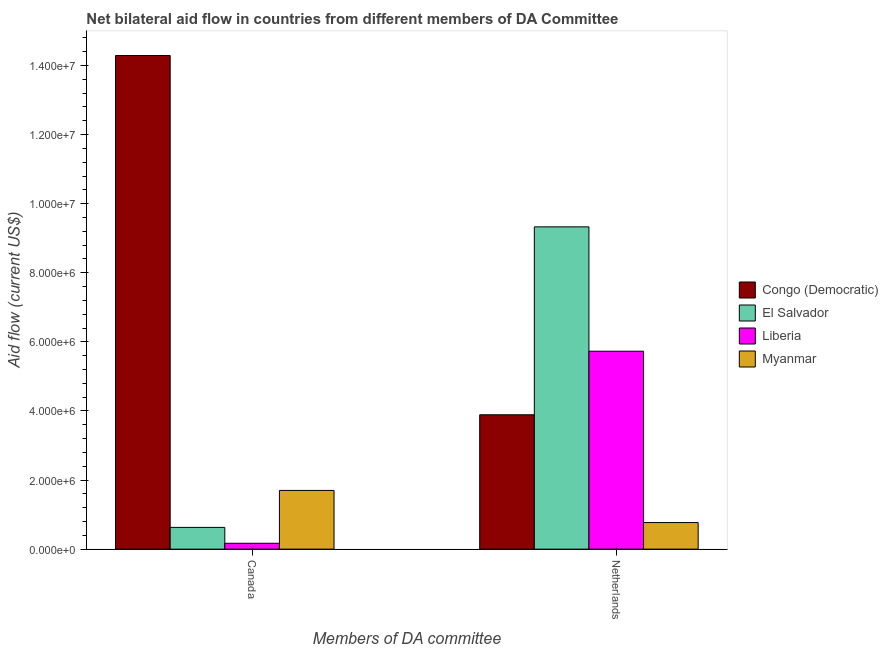How many different coloured bars are there?
Offer a terse response. 4. How many groups of bars are there?
Provide a short and direct response. 2. Are the number of bars per tick equal to the number of legend labels?
Your answer should be very brief. Yes. How many bars are there on the 2nd tick from the right?
Provide a succinct answer. 4. What is the amount of aid given by netherlands in Congo (Democratic)?
Keep it short and to the point. 3.89e+06. Across all countries, what is the maximum amount of aid given by canada?
Your answer should be very brief. 1.43e+07. Across all countries, what is the minimum amount of aid given by netherlands?
Give a very brief answer. 7.70e+05. In which country was the amount of aid given by netherlands maximum?
Offer a very short reply. El Salvador. In which country was the amount of aid given by netherlands minimum?
Provide a short and direct response. Myanmar. What is the total amount of aid given by netherlands in the graph?
Offer a terse response. 1.97e+07. What is the difference between the amount of aid given by canada in Myanmar and that in Liberia?
Your answer should be very brief. 1.53e+06. What is the difference between the amount of aid given by netherlands in Liberia and the amount of aid given by canada in Congo (Democratic)?
Your answer should be very brief. -8.56e+06. What is the average amount of aid given by netherlands per country?
Give a very brief answer. 4.93e+06. What is the difference between the amount of aid given by netherlands and amount of aid given by canada in Liberia?
Offer a terse response. 5.56e+06. What is the ratio of the amount of aid given by netherlands in Liberia to that in Myanmar?
Offer a very short reply. 7.44. In how many countries, is the amount of aid given by netherlands greater than the average amount of aid given by netherlands taken over all countries?
Provide a short and direct response. 2. What does the 3rd bar from the left in Canada represents?
Ensure brevity in your answer.  Liberia. What does the 2nd bar from the right in Netherlands represents?
Offer a terse response. Liberia. Are the values on the major ticks of Y-axis written in scientific E-notation?
Your response must be concise. Yes. Does the graph contain any zero values?
Your answer should be very brief. No. Where does the legend appear in the graph?
Ensure brevity in your answer.  Center right. How are the legend labels stacked?
Your answer should be compact. Vertical. What is the title of the graph?
Your answer should be very brief. Net bilateral aid flow in countries from different members of DA Committee. Does "Serbia" appear as one of the legend labels in the graph?
Your response must be concise. No. What is the label or title of the X-axis?
Keep it short and to the point. Members of DA committee. What is the label or title of the Y-axis?
Ensure brevity in your answer.  Aid flow (current US$). What is the Aid flow (current US$) in Congo (Democratic) in Canada?
Ensure brevity in your answer.  1.43e+07. What is the Aid flow (current US$) in El Salvador in Canada?
Offer a terse response. 6.30e+05. What is the Aid flow (current US$) of Liberia in Canada?
Give a very brief answer. 1.70e+05. What is the Aid flow (current US$) of Myanmar in Canada?
Give a very brief answer. 1.70e+06. What is the Aid flow (current US$) in Congo (Democratic) in Netherlands?
Give a very brief answer. 3.89e+06. What is the Aid flow (current US$) in El Salvador in Netherlands?
Your response must be concise. 9.33e+06. What is the Aid flow (current US$) of Liberia in Netherlands?
Ensure brevity in your answer.  5.73e+06. What is the Aid flow (current US$) in Myanmar in Netherlands?
Your response must be concise. 7.70e+05. Across all Members of DA committee, what is the maximum Aid flow (current US$) of Congo (Democratic)?
Your response must be concise. 1.43e+07. Across all Members of DA committee, what is the maximum Aid flow (current US$) in El Salvador?
Make the answer very short. 9.33e+06. Across all Members of DA committee, what is the maximum Aid flow (current US$) in Liberia?
Make the answer very short. 5.73e+06. Across all Members of DA committee, what is the maximum Aid flow (current US$) in Myanmar?
Provide a succinct answer. 1.70e+06. Across all Members of DA committee, what is the minimum Aid flow (current US$) in Congo (Democratic)?
Give a very brief answer. 3.89e+06. Across all Members of DA committee, what is the minimum Aid flow (current US$) of El Salvador?
Give a very brief answer. 6.30e+05. Across all Members of DA committee, what is the minimum Aid flow (current US$) in Liberia?
Make the answer very short. 1.70e+05. Across all Members of DA committee, what is the minimum Aid flow (current US$) in Myanmar?
Give a very brief answer. 7.70e+05. What is the total Aid flow (current US$) of Congo (Democratic) in the graph?
Offer a terse response. 1.82e+07. What is the total Aid flow (current US$) in El Salvador in the graph?
Offer a terse response. 9.96e+06. What is the total Aid flow (current US$) in Liberia in the graph?
Your answer should be compact. 5.90e+06. What is the total Aid flow (current US$) of Myanmar in the graph?
Make the answer very short. 2.47e+06. What is the difference between the Aid flow (current US$) of Congo (Democratic) in Canada and that in Netherlands?
Provide a succinct answer. 1.04e+07. What is the difference between the Aid flow (current US$) of El Salvador in Canada and that in Netherlands?
Keep it short and to the point. -8.70e+06. What is the difference between the Aid flow (current US$) of Liberia in Canada and that in Netherlands?
Your answer should be very brief. -5.56e+06. What is the difference between the Aid flow (current US$) of Myanmar in Canada and that in Netherlands?
Provide a succinct answer. 9.30e+05. What is the difference between the Aid flow (current US$) of Congo (Democratic) in Canada and the Aid flow (current US$) of El Salvador in Netherlands?
Provide a succinct answer. 4.96e+06. What is the difference between the Aid flow (current US$) of Congo (Democratic) in Canada and the Aid flow (current US$) of Liberia in Netherlands?
Provide a succinct answer. 8.56e+06. What is the difference between the Aid flow (current US$) in Congo (Democratic) in Canada and the Aid flow (current US$) in Myanmar in Netherlands?
Keep it short and to the point. 1.35e+07. What is the difference between the Aid flow (current US$) of El Salvador in Canada and the Aid flow (current US$) of Liberia in Netherlands?
Offer a terse response. -5.10e+06. What is the difference between the Aid flow (current US$) in El Salvador in Canada and the Aid flow (current US$) in Myanmar in Netherlands?
Keep it short and to the point. -1.40e+05. What is the difference between the Aid flow (current US$) in Liberia in Canada and the Aid flow (current US$) in Myanmar in Netherlands?
Your response must be concise. -6.00e+05. What is the average Aid flow (current US$) of Congo (Democratic) per Members of DA committee?
Give a very brief answer. 9.09e+06. What is the average Aid flow (current US$) of El Salvador per Members of DA committee?
Ensure brevity in your answer.  4.98e+06. What is the average Aid flow (current US$) in Liberia per Members of DA committee?
Offer a very short reply. 2.95e+06. What is the average Aid flow (current US$) in Myanmar per Members of DA committee?
Your answer should be very brief. 1.24e+06. What is the difference between the Aid flow (current US$) in Congo (Democratic) and Aid flow (current US$) in El Salvador in Canada?
Keep it short and to the point. 1.37e+07. What is the difference between the Aid flow (current US$) of Congo (Democratic) and Aid flow (current US$) of Liberia in Canada?
Offer a terse response. 1.41e+07. What is the difference between the Aid flow (current US$) in Congo (Democratic) and Aid flow (current US$) in Myanmar in Canada?
Ensure brevity in your answer.  1.26e+07. What is the difference between the Aid flow (current US$) in El Salvador and Aid flow (current US$) in Liberia in Canada?
Make the answer very short. 4.60e+05. What is the difference between the Aid flow (current US$) in El Salvador and Aid flow (current US$) in Myanmar in Canada?
Your answer should be very brief. -1.07e+06. What is the difference between the Aid flow (current US$) of Liberia and Aid flow (current US$) of Myanmar in Canada?
Give a very brief answer. -1.53e+06. What is the difference between the Aid flow (current US$) of Congo (Democratic) and Aid flow (current US$) of El Salvador in Netherlands?
Your answer should be very brief. -5.44e+06. What is the difference between the Aid flow (current US$) of Congo (Democratic) and Aid flow (current US$) of Liberia in Netherlands?
Provide a succinct answer. -1.84e+06. What is the difference between the Aid flow (current US$) in Congo (Democratic) and Aid flow (current US$) in Myanmar in Netherlands?
Your answer should be very brief. 3.12e+06. What is the difference between the Aid flow (current US$) of El Salvador and Aid flow (current US$) of Liberia in Netherlands?
Keep it short and to the point. 3.60e+06. What is the difference between the Aid flow (current US$) of El Salvador and Aid flow (current US$) of Myanmar in Netherlands?
Ensure brevity in your answer.  8.56e+06. What is the difference between the Aid flow (current US$) in Liberia and Aid flow (current US$) in Myanmar in Netherlands?
Provide a succinct answer. 4.96e+06. What is the ratio of the Aid flow (current US$) in Congo (Democratic) in Canada to that in Netherlands?
Your answer should be very brief. 3.67. What is the ratio of the Aid flow (current US$) in El Salvador in Canada to that in Netherlands?
Offer a very short reply. 0.07. What is the ratio of the Aid flow (current US$) in Liberia in Canada to that in Netherlands?
Keep it short and to the point. 0.03. What is the ratio of the Aid flow (current US$) in Myanmar in Canada to that in Netherlands?
Your answer should be very brief. 2.21. What is the difference between the highest and the second highest Aid flow (current US$) in Congo (Democratic)?
Keep it short and to the point. 1.04e+07. What is the difference between the highest and the second highest Aid flow (current US$) of El Salvador?
Make the answer very short. 8.70e+06. What is the difference between the highest and the second highest Aid flow (current US$) in Liberia?
Offer a very short reply. 5.56e+06. What is the difference between the highest and the second highest Aid flow (current US$) of Myanmar?
Make the answer very short. 9.30e+05. What is the difference between the highest and the lowest Aid flow (current US$) in Congo (Democratic)?
Give a very brief answer. 1.04e+07. What is the difference between the highest and the lowest Aid flow (current US$) in El Salvador?
Provide a succinct answer. 8.70e+06. What is the difference between the highest and the lowest Aid flow (current US$) in Liberia?
Ensure brevity in your answer.  5.56e+06. What is the difference between the highest and the lowest Aid flow (current US$) of Myanmar?
Your answer should be compact. 9.30e+05. 